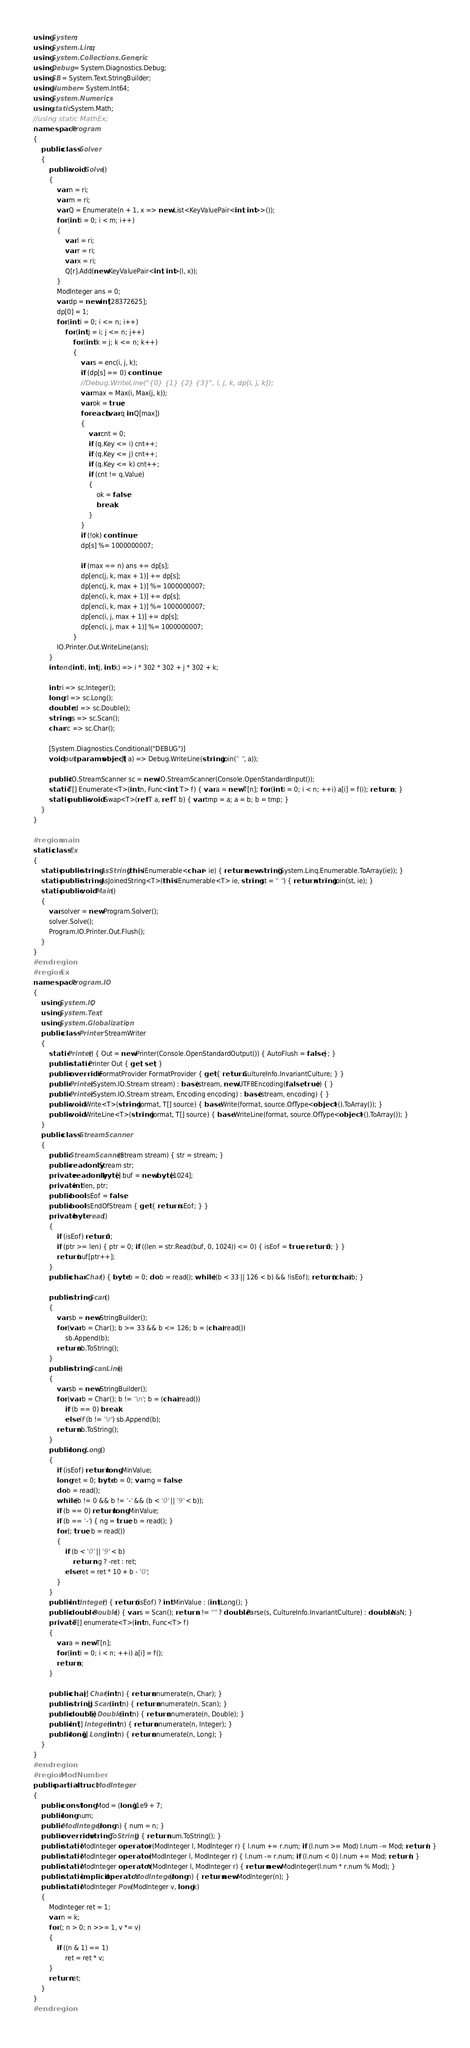Convert code to text. <code><loc_0><loc_0><loc_500><loc_500><_C#_>using System;
using System.Linq;
using System.Collections.Generic;
using Debug = System.Diagnostics.Debug;
using SB = System.Text.StringBuilder;
using Number = System.Int64;
using System.Numerics;
using static System.Math;
//using static MathEx;
namespace Program
{
    public class Solver
    {
        public void Solve()
        {
            var n = ri;
            var m = ri;
            var Q = Enumerate(n + 1, x => new List<KeyValuePair<int, int>>());
            for (int i = 0; i < m; i++)
            {
                var l = ri;
                var r = ri;
                var x = ri;
                Q[r].Add(new KeyValuePair<int, int>(l, x));
            }
            ModInteger ans = 0;
            var dp = new int[28372625];
            dp[0] = 1;
            for (int i = 0; i <= n; i++)
                for (int j = i; j <= n; j++)
                    for (int k = j; k <= n; k++)
                    {
                        var s = enc(i, j, k);
                        if (dp[s] == 0) continue;
                        //Debug.WriteLine("{0} {1} {2} {3}", i, j, k, dp[i, j, k]);
                        var max = Max(i, Max(j, k));
                        var ok = true;
                        foreach (var q in Q[max])
                        {
                            var cnt = 0;
                            if (q.Key <= i) cnt++;
                            if (q.Key <= j) cnt++;
                            if (q.Key <= k) cnt++;
                            if (cnt != q.Value)
                            {
                                ok = false;
                                break;
                            }
                        }
                        if (!ok) continue;
                        dp[s] %= 1000000007;

                        if (max == n) ans += dp[s];
                        dp[enc(j, k, max + 1)] += dp[s];
                        dp[enc(j, k, max + 1)] %= 1000000007;
                        dp[enc(i, k, max + 1)] += dp[s];
                        dp[enc(i, k, max + 1)] %= 1000000007;
                        dp[enc(i, j, max + 1)] += dp[s];
                        dp[enc(i, j, max + 1)] %= 1000000007;
                    }
            IO.Printer.Out.WriteLine(ans);
        }
        int enc(int i, int j, int k) => i * 302 * 302 + j * 302 + k;

        int ri => sc.Integer();
        long rl => sc.Long();
        double rd => sc.Double();
        string rs => sc.Scan();
        char rc => sc.Char();

        [System.Diagnostics.Conditional("DEBUG")]
        void put(params object[] a) => Debug.WriteLine(string.Join(" ", a));

        public IO.StreamScanner sc = new IO.StreamScanner(Console.OpenStandardInput());
        static T[] Enumerate<T>(int n, Func<int, T> f) { var a = new T[n]; for (int i = 0; i < n; ++i) a[i] = f(i); return a; }
        static public void Swap<T>(ref T a, ref T b) { var tmp = a; a = b; b = tmp; }
    }
}

#region main
static class Ex
{
    static public string AsString(this IEnumerable<char> ie) { return new string(System.Linq.Enumerable.ToArray(ie)); }
    static public string AsJoinedString<T>(this IEnumerable<T> ie, string st = " ") { return string.Join(st, ie); }
    static public void Main()
    {
        var solver = new Program.Solver();
        solver.Solve();
        Program.IO.Printer.Out.Flush();
    }
}
#endregion
#region Ex
namespace Program.IO
{
    using System.IO;
    using System.Text;
    using System.Globalization;
    public class Printer: StreamWriter
    {
        static Printer() { Out = new Printer(Console.OpenStandardOutput()) { AutoFlush = false }; }
        public static Printer Out { get; set; }
        public override IFormatProvider FormatProvider { get { return CultureInfo.InvariantCulture; } }
        public Printer(System.IO.Stream stream) : base(stream, new UTF8Encoding(false, true)) { }
        public Printer(System.IO.Stream stream, Encoding encoding) : base(stream, encoding) { }
        public void Write<T>(string format, T[] source) { base.Write(format, source.OfType<object>().ToArray()); }
        public void WriteLine<T>(string format, T[] source) { base.WriteLine(format, source.OfType<object>().ToArray()); }
    }
    public class StreamScanner
    {
        public StreamScanner(Stream stream) { str = stream; }
        public readonly Stream str;
        private readonly byte[] buf = new byte[1024];
        private int len, ptr;
        public bool isEof = false;
        public bool IsEndOfStream { get { return isEof; } }
        private byte read()
        {
            if (isEof) return 0;
            if (ptr >= len) { ptr = 0; if ((len = str.Read(buf, 0, 1024)) <= 0) { isEof = true; return 0; } }
            return buf[ptr++];
        }
        public char Char() { byte b = 0; do b = read(); while ((b < 33 || 126 < b) && !isEof); return (char)b; }

        public string Scan()
        {
            var sb = new StringBuilder();
            for (var b = Char(); b >= 33 && b <= 126; b = (char)read())
                sb.Append(b);
            return sb.ToString();
        }
        public string ScanLine()
        {
            var sb = new StringBuilder();
            for (var b = Char(); b != '\n'; b = (char)read())
                if (b == 0) break;
                else if (b != '\r') sb.Append(b);
            return sb.ToString();
        }
        public long Long()
        {
            if (isEof) return long.MinValue;
            long ret = 0; byte b = 0; var ng = false;
            do b = read();
            while (b != 0 && b != '-' && (b < '0' || '9' < b));
            if (b == 0) return long.MinValue;
            if (b == '-') { ng = true; b = read(); }
            for (; true; b = read())
            {
                if (b < '0' || '9' < b)
                    return ng ? -ret : ret;
                else ret = ret * 10 + b - '0';
            }
        }
        public int Integer() { return (isEof) ? int.MinValue : (int)Long(); }
        public double Double() { var s = Scan(); return s != "" ? double.Parse(s, CultureInfo.InvariantCulture) : double.NaN; }
        private T[] enumerate<T>(int n, Func<T> f)
        {
            var a = new T[n];
            for (int i = 0; i < n; ++i) a[i] = f();
            return a;
        }

        public char[] Char(int n) { return enumerate(n, Char); }
        public string[] Scan(int n) { return enumerate(n, Scan); }
        public double[] Double(int n) { return enumerate(n, Double); }
        public int[] Integer(int n) { return enumerate(n, Integer); }
        public long[] Long(int n) { return enumerate(n, Long); }
    }
}
#endregion
#region ModNumber
public partial struct ModInteger
{
    public const long Mod = (long)1e9 + 7;
    public long num;
    public ModInteger(long n) { num = n; }
    public override string ToString() { return num.ToString(); }
    public static ModInteger operator +(ModInteger l, ModInteger r) { l.num += r.num; if (l.num >= Mod) l.num -= Mod; return l; }
    public static ModInteger operator -(ModInteger l, ModInteger r) { l.num -= r.num; if (l.num < 0) l.num += Mod; return l; }
    public static ModInteger operator *(ModInteger l, ModInteger r) { return new ModInteger(l.num * r.num % Mod); }
    public static implicit operator ModInteger(long n) { return new ModInteger(n); }
    public static ModInteger Pow(ModInteger v, long k)
    {
        ModInteger ret = 1;
        var n = k;
        for (; n > 0; n >>= 1, v *= v)
        {
            if ((n & 1) == 1)
                ret = ret * v;
        }
        return ret;
    }
}
#endregion</code> 